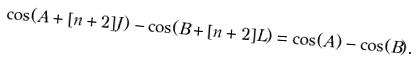Convert formula to latex. <formula><loc_0><loc_0><loc_500><loc_500>\cos ( A + [ n + 2 ] J ) - \cos ( B + [ n + 2 ] L ) = \cos ( A ) - \cos ( B ) .</formula> 